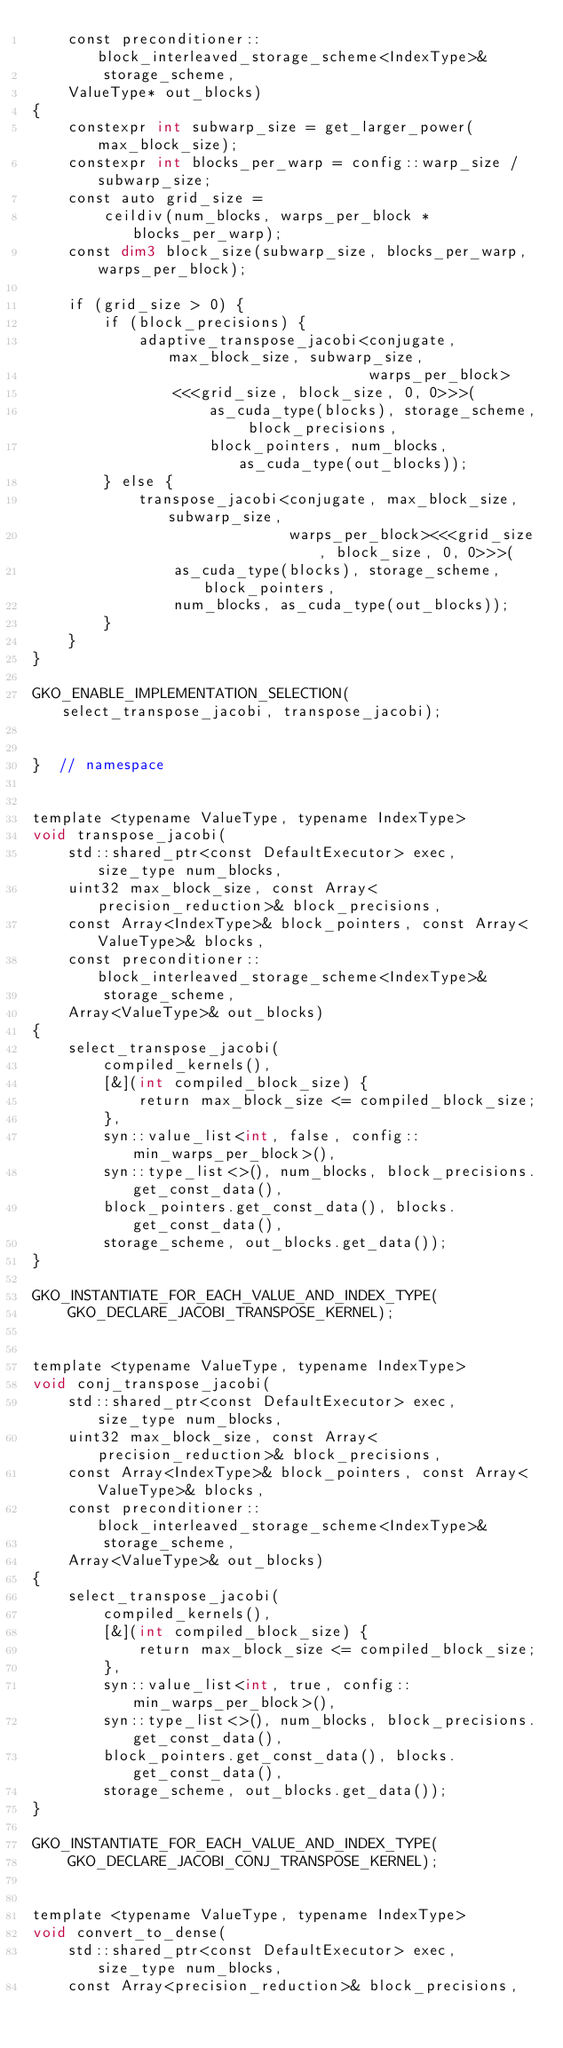Convert code to text. <code><loc_0><loc_0><loc_500><loc_500><_Cuda_>    const preconditioner::block_interleaved_storage_scheme<IndexType>&
        storage_scheme,
    ValueType* out_blocks)
{
    constexpr int subwarp_size = get_larger_power(max_block_size);
    constexpr int blocks_per_warp = config::warp_size / subwarp_size;
    const auto grid_size =
        ceildiv(num_blocks, warps_per_block * blocks_per_warp);
    const dim3 block_size(subwarp_size, blocks_per_warp, warps_per_block);

    if (grid_size > 0) {
        if (block_precisions) {
            adaptive_transpose_jacobi<conjugate, max_block_size, subwarp_size,
                                      warps_per_block>
                <<<grid_size, block_size, 0, 0>>>(
                    as_cuda_type(blocks), storage_scheme, block_precisions,
                    block_pointers, num_blocks, as_cuda_type(out_blocks));
        } else {
            transpose_jacobi<conjugate, max_block_size, subwarp_size,
                             warps_per_block><<<grid_size, block_size, 0, 0>>>(
                as_cuda_type(blocks), storage_scheme, block_pointers,
                num_blocks, as_cuda_type(out_blocks));
        }
    }
}

GKO_ENABLE_IMPLEMENTATION_SELECTION(select_transpose_jacobi, transpose_jacobi);


}  // namespace


template <typename ValueType, typename IndexType>
void transpose_jacobi(
    std::shared_ptr<const DefaultExecutor> exec, size_type num_blocks,
    uint32 max_block_size, const Array<precision_reduction>& block_precisions,
    const Array<IndexType>& block_pointers, const Array<ValueType>& blocks,
    const preconditioner::block_interleaved_storage_scheme<IndexType>&
        storage_scheme,
    Array<ValueType>& out_blocks)
{
    select_transpose_jacobi(
        compiled_kernels(),
        [&](int compiled_block_size) {
            return max_block_size <= compiled_block_size;
        },
        syn::value_list<int, false, config::min_warps_per_block>(),
        syn::type_list<>(), num_blocks, block_precisions.get_const_data(),
        block_pointers.get_const_data(), blocks.get_const_data(),
        storage_scheme, out_blocks.get_data());
}

GKO_INSTANTIATE_FOR_EACH_VALUE_AND_INDEX_TYPE(
    GKO_DECLARE_JACOBI_TRANSPOSE_KERNEL);


template <typename ValueType, typename IndexType>
void conj_transpose_jacobi(
    std::shared_ptr<const DefaultExecutor> exec, size_type num_blocks,
    uint32 max_block_size, const Array<precision_reduction>& block_precisions,
    const Array<IndexType>& block_pointers, const Array<ValueType>& blocks,
    const preconditioner::block_interleaved_storage_scheme<IndexType>&
        storage_scheme,
    Array<ValueType>& out_blocks)
{
    select_transpose_jacobi(
        compiled_kernels(),
        [&](int compiled_block_size) {
            return max_block_size <= compiled_block_size;
        },
        syn::value_list<int, true, config::min_warps_per_block>(),
        syn::type_list<>(), num_blocks, block_precisions.get_const_data(),
        block_pointers.get_const_data(), blocks.get_const_data(),
        storage_scheme, out_blocks.get_data());
}

GKO_INSTANTIATE_FOR_EACH_VALUE_AND_INDEX_TYPE(
    GKO_DECLARE_JACOBI_CONJ_TRANSPOSE_KERNEL);


template <typename ValueType, typename IndexType>
void convert_to_dense(
    std::shared_ptr<const DefaultExecutor> exec, size_type num_blocks,
    const Array<precision_reduction>& block_precisions,</code> 